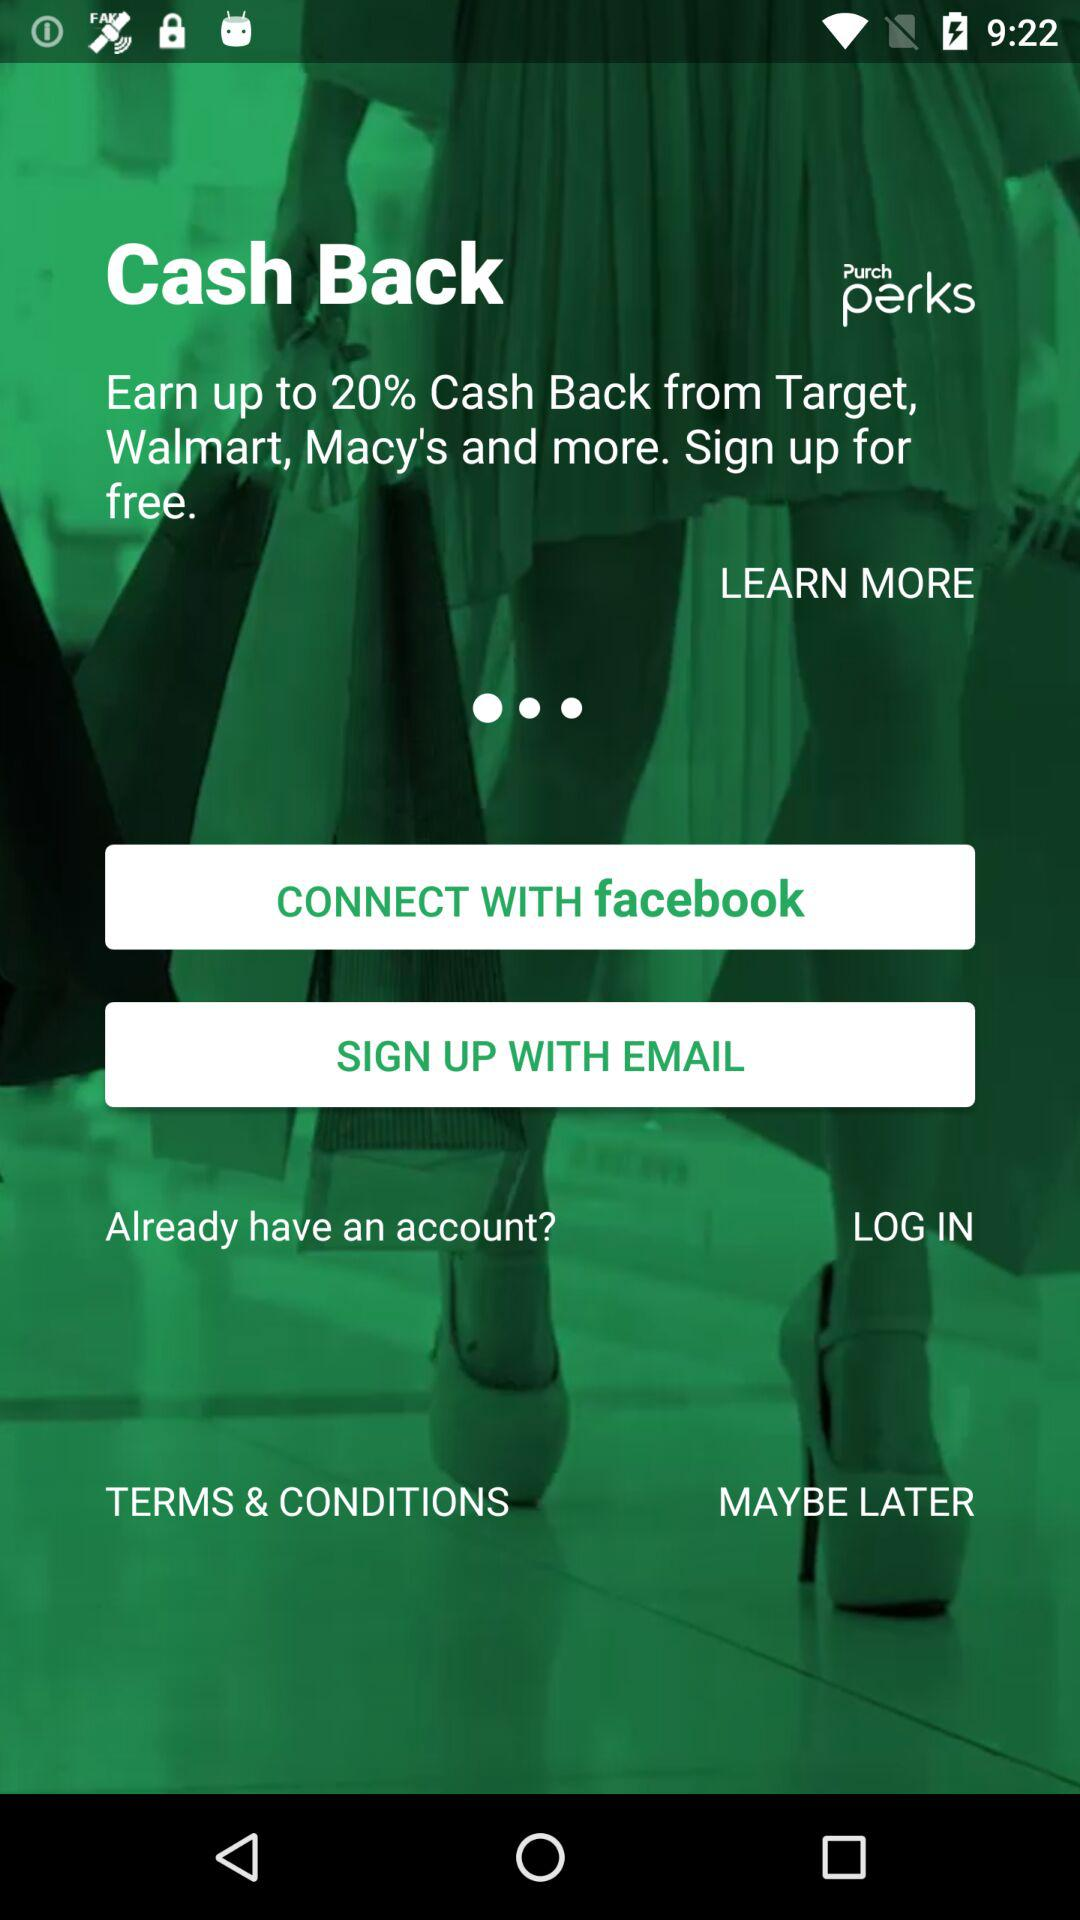How much cashback can we earn? You can earn up to 20% cashback. 